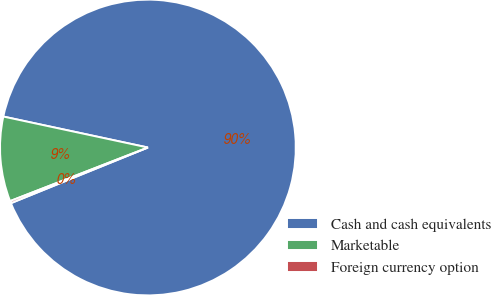<chart> <loc_0><loc_0><loc_500><loc_500><pie_chart><fcel>Cash and cash equivalents<fcel>Marketable<fcel>Foreign currency option<nl><fcel>90.5%<fcel>9.26%<fcel>0.24%<nl></chart> 